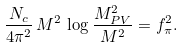<formula> <loc_0><loc_0><loc_500><loc_500>\frac { N _ { c } } { 4 \pi ^ { 2 } } \, M ^ { 2 } \, \log \frac { M _ { P V } ^ { 2 } } { M ^ { 2 } } = f _ { \pi } ^ { 2 } .</formula> 